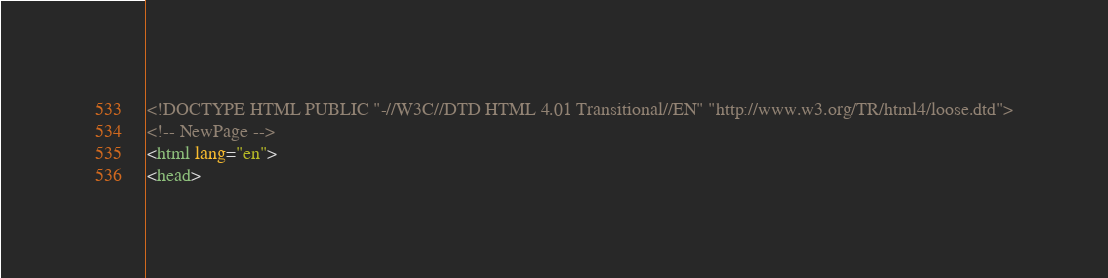Convert code to text. <code><loc_0><loc_0><loc_500><loc_500><_HTML_><!DOCTYPE HTML PUBLIC "-//W3C//DTD HTML 4.01 Transitional//EN" "http://www.w3.org/TR/html4/loose.dtd">
<!-- NewPage -->
<html lang="en">
<head></code> 